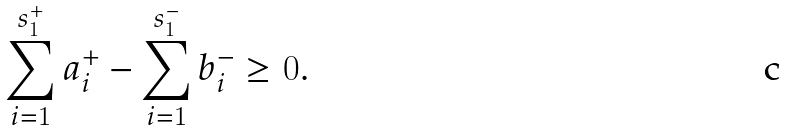<formula> <loc_0><loc_0><loc_500><loc_500>\sum _ { i = 1 } ^ { s _ { 1 } ^ { + } } a ^ { + } _ { i } - \sum _ { i = 1 } ^ { s _ { 1 } ^ { - } } b ^ { - } _ { i } \geq 0 .</formula> 